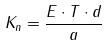<formula> <loc_0><loc_0><loc_500><loc_500>K _ { n } = \frac { E \cdot T \cdot d } { a }</formula> 